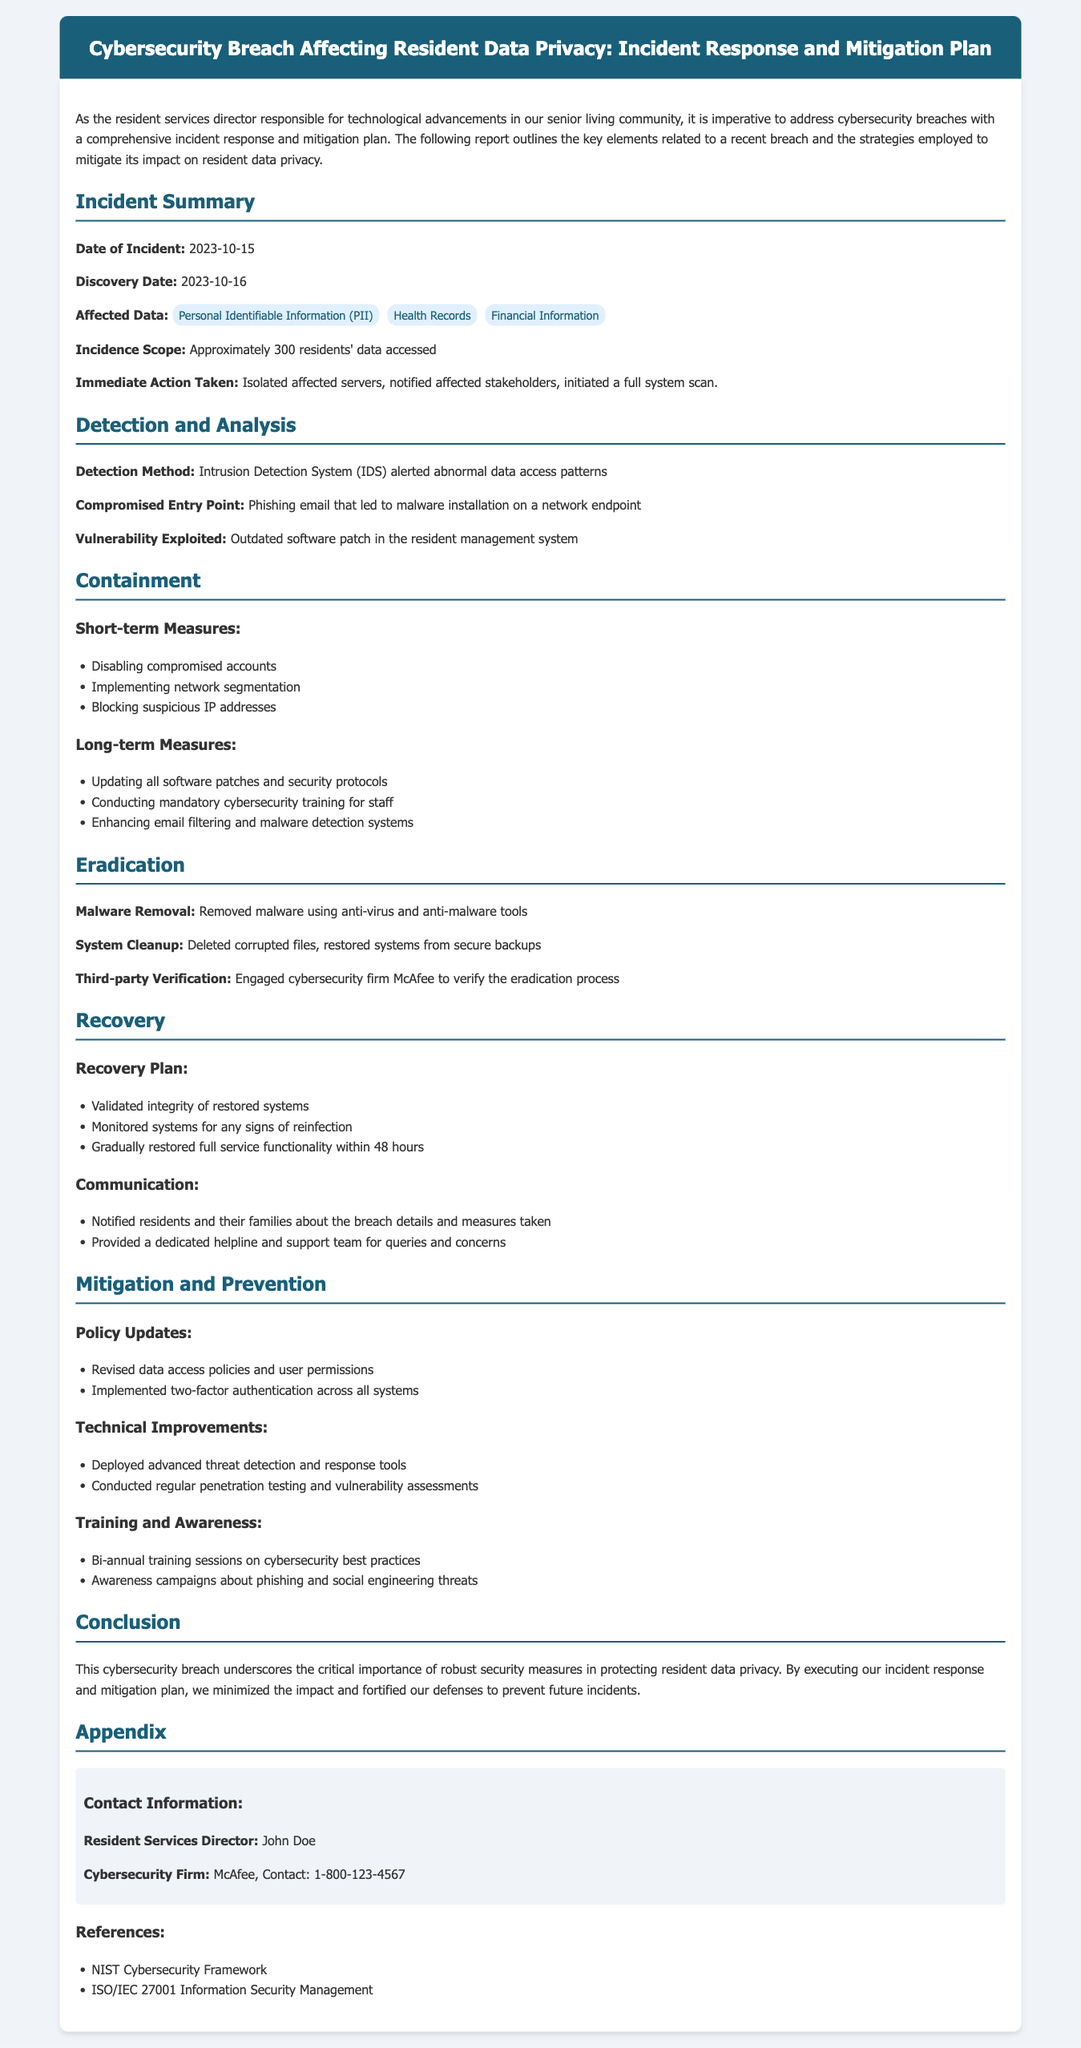What was the date of the incident? The date of the incident is specified in the document as when the breach occurred.
Answer: 2023-10-15 How many residents' data was accessed? The document mentions the approximate number of residents affected by the breach.
Answer: Approximately 300 residents Who was engaged for third-party verification? The report specifies the cybersecurity firm that was contacted for the verification process.
Answer: McAfee What immediate action was taken after the incident? The document lists the first step taken following the discovery of the breach.
Answer: Isolated affected servers What detection method triggered the alarm? The document describes the system that alerted us about abnormal data access patterns.
Answer: Intrusion Detection System What were the long-term containment measures? The report outlines the strategies implemented to prevent future occurrences of similar breaches.
Answer: Updating all software patches and security protocols When was the incident discovered? The document provides the date when the breach was identified.
Answer: 2023-10-16 What type of information was affected by the breach? The document categorizes the types of data that were compromised during the incident.
Answer: Personal Identifiable Information, Health Records, Financial Information What communication was provided to residents after the breach? The document states how residents and their families were informed about the breach.
Answer: Notified residents and their families about the breach details and measures taken 